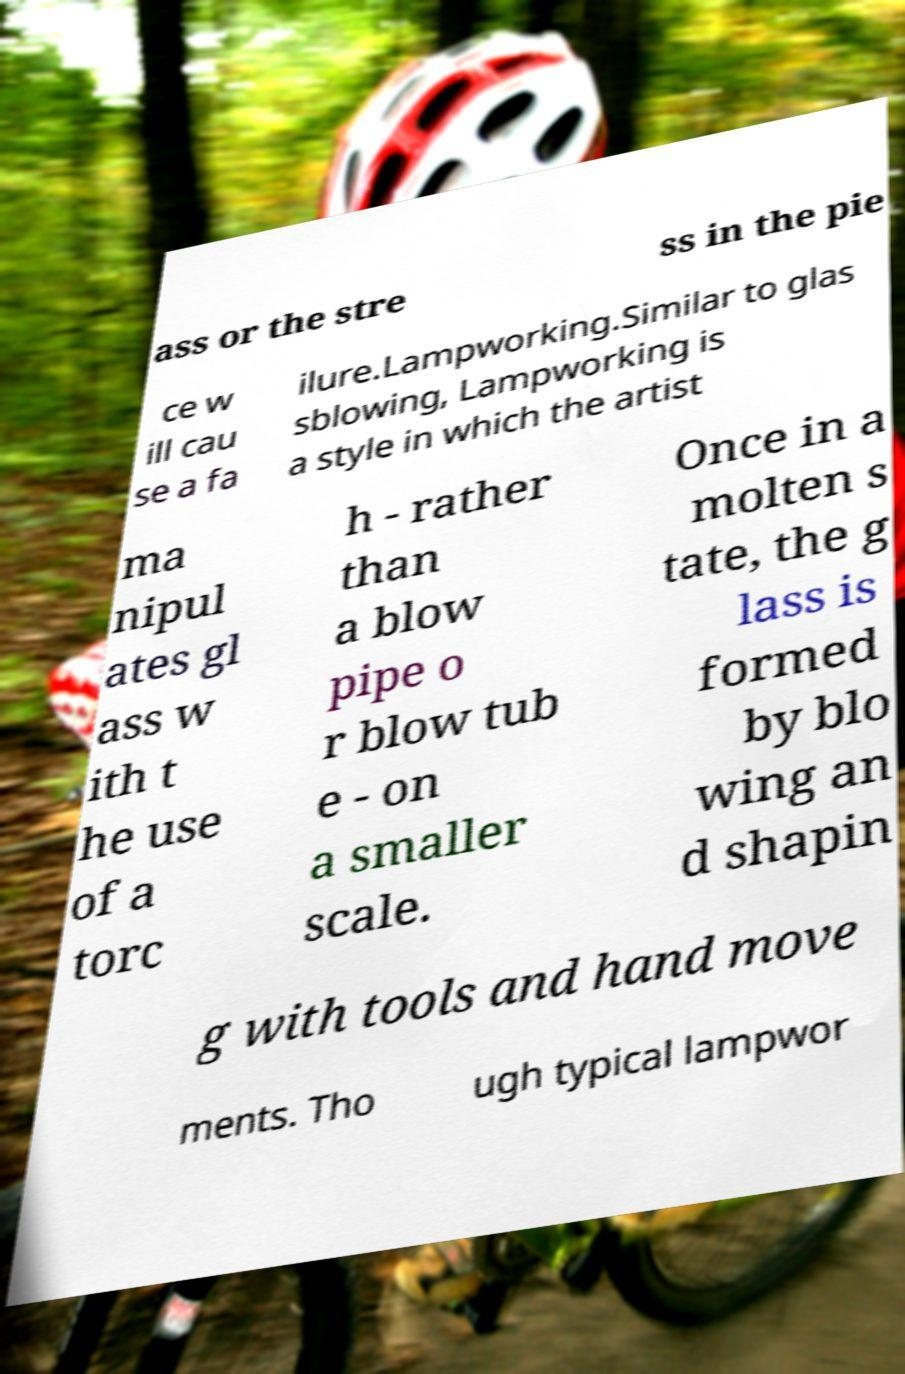I need the written content from this picture converted into text. Can you do that? ass or the stre ss in the pie ce w ill cau se a fa ilure.Lampworking.Similar to glas sblowing, Lampworking is a style in which the artist ma nipul ates gl ass w ith t he use of a torc h - rather than a blow pipe o r blow tub e - on a smaller scale. Once in a molten s tate, the g lass is formed by blo wing an d shapin g with tools and hand move ments. Tho ugh typical lampwor 